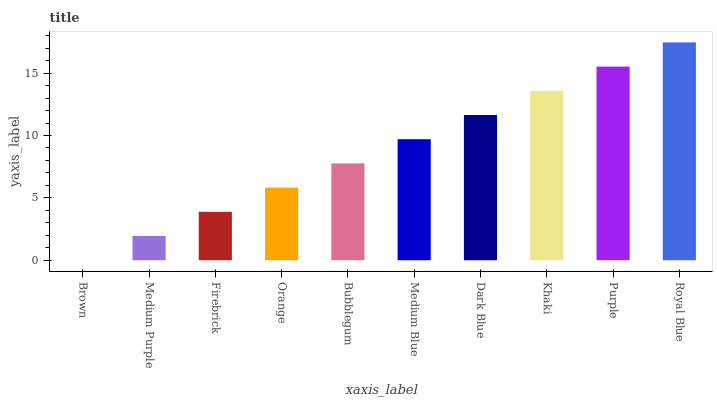Is Brown the minimum?
Answer yes or no. Yes. Is Royal Blue the maximum?
Answer yes or no. Yes. Is Medium Purple the minimum?
Answer yes or no. No. Is Medium Purple the maximum?
Answer yes or no. No. Is Medium Purple greater than Brown?
Answer yes or no. Yes. Is Brown less than Medium Purple?
Answer yes or no. Yes. Is Brown greater than Medium Purple?
Answer yes or no. No. Is Medium Purple less than Brown?
Answer yes or no. No. Is Medium Blue the high median?
Answer yes or no. Yes. Is Bubblegum the low median?
Answer yes or no. Yes. Is Purple the high median?
Answer yes or no. No. Is Brown the low median?
Answer yes or no. No. 